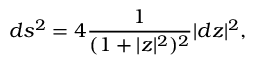Convert formula to latex. <formula><loc_0><loc_0><loc_500><loc_500>d s ^ { 2 } = 4 \frac { 1 } { ( 1 + | z | ^ { 2 } ) ^ { 2 } } | d z | ^ { 2 } ,</formula> 